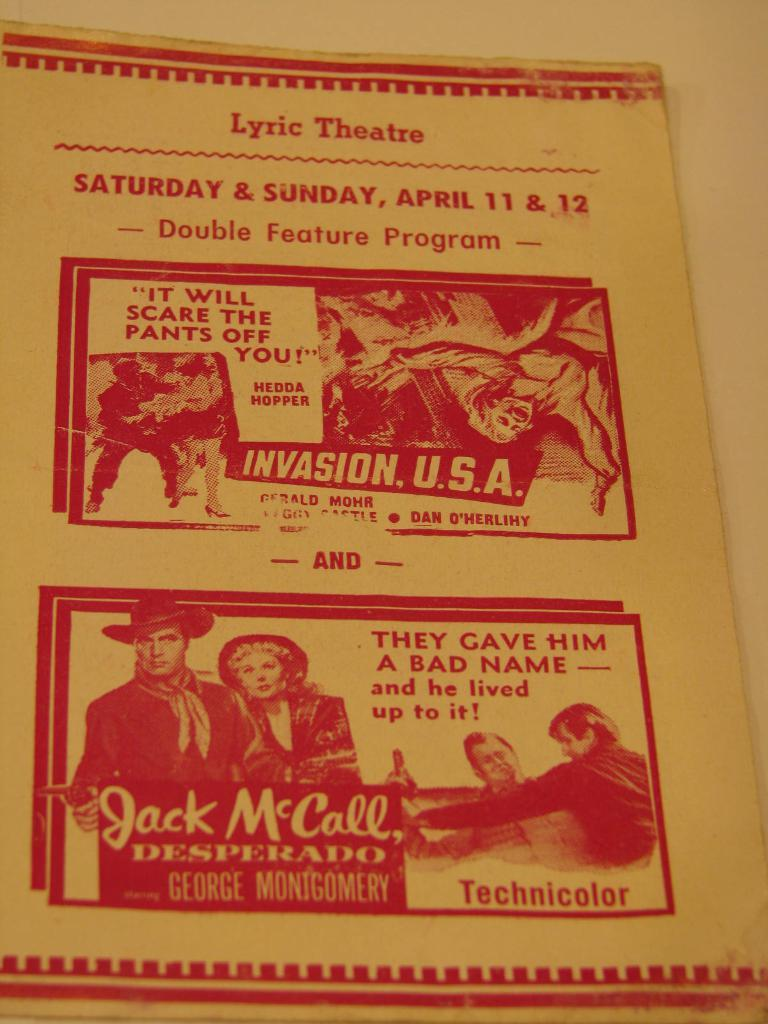<image>
Render a clear and concise summary of the photo. An old poster for the Lyric theatre advertising 2 films on April 11 & 12 